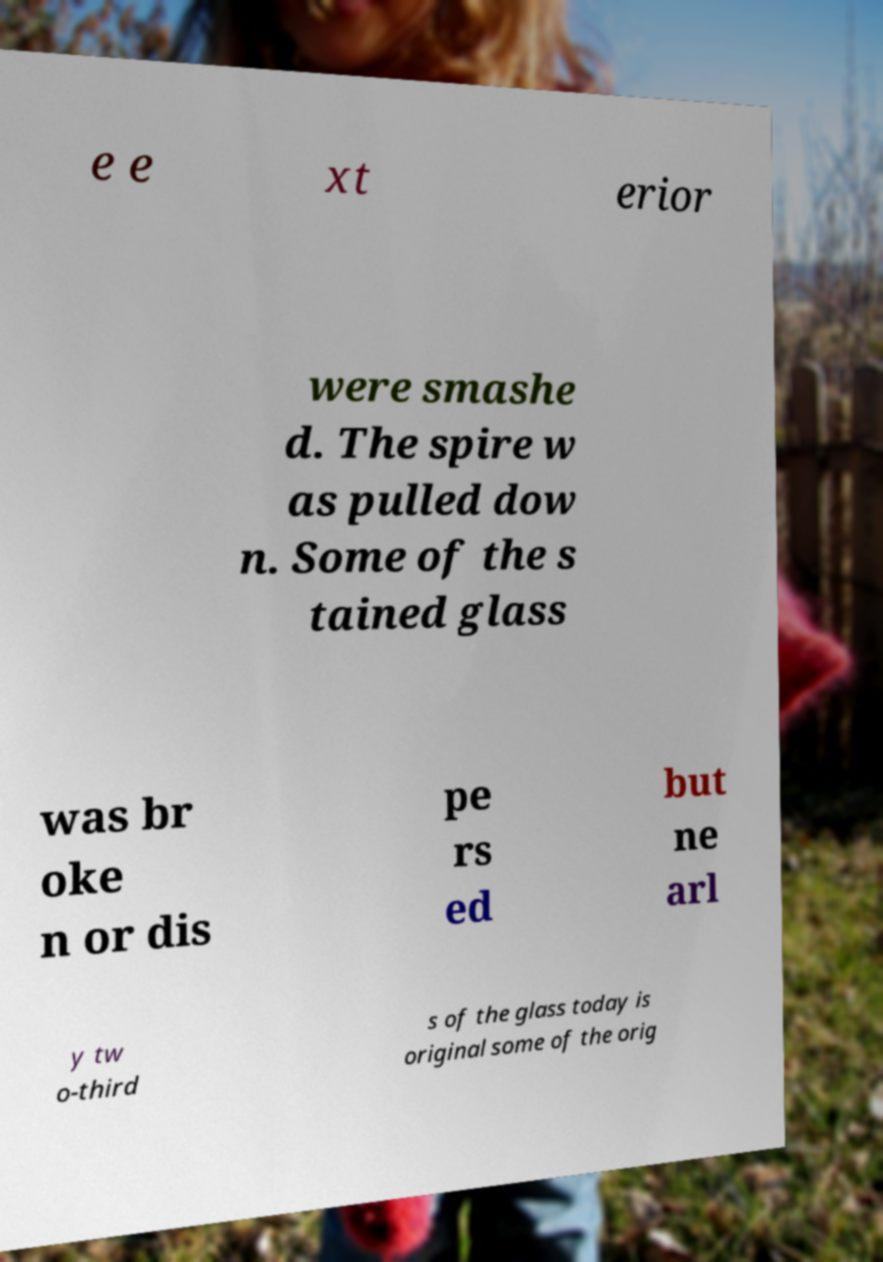Please read and relay the text visible in this image. What does it say? e e xt erior were smashe d. The spire w as pulled dow n. Some of the s tained glass was br oke n or dis pe rs ed but ne arl y tw o-third s of the glass today is original some of the orig 